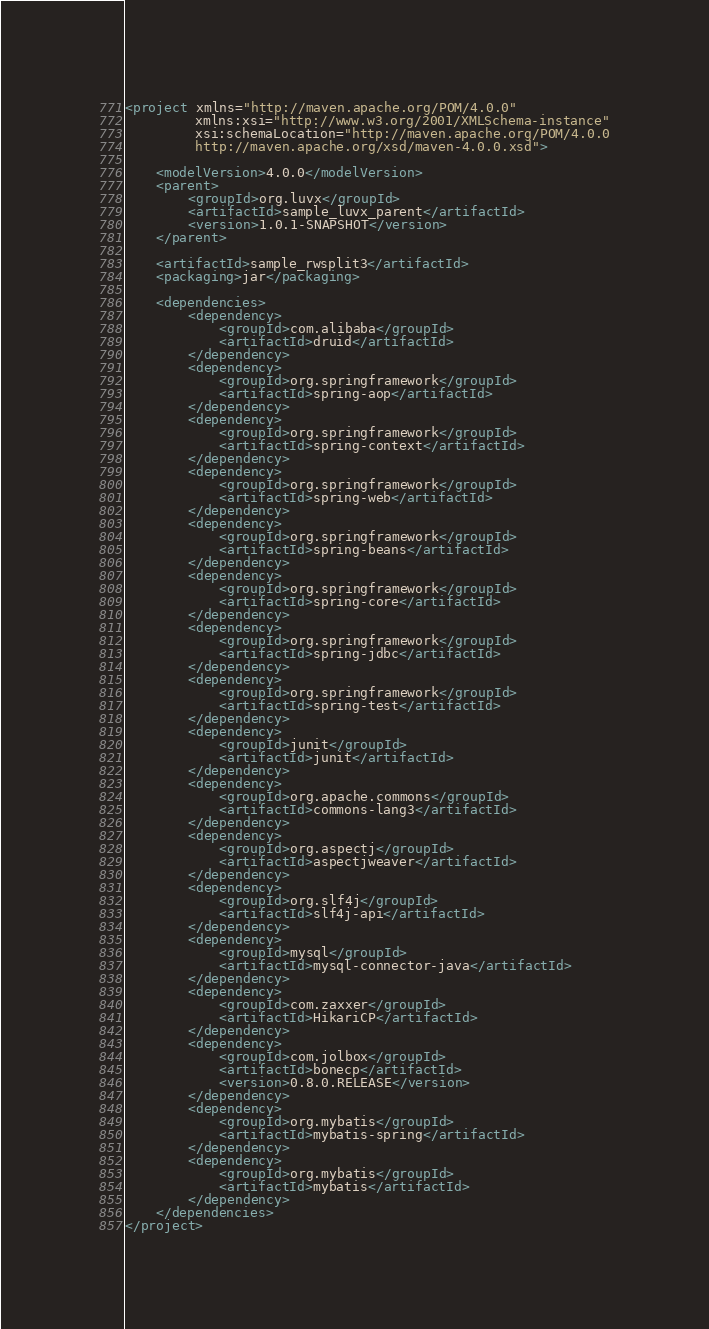<code> <loc_0><loc_0><loc_500><loc_500><_XML_><project xmlns="http://maven.apache.org/POM/4.0.0"
         xmlns:xsi="http://www.w3.org/2001/XMLSchema-instance"
         xsi:schemaLocation="http://maven.apache.org/POM/4.0.0
         http://maven.apache.org/xsd/maven-4.0.0.xsd">

    <modelVersion>4.0.0</modelVersion>
    <parent>
        <groupId>org.luvx</groupId>
        <artifactId>sample_luvx_parent</artifactId>
        <version>1.0.1-SNAPSHOT</version>
    </parent>

    <artifactId>sample_rwsplit3</artifactId>
    <packaging>jar</packaging>

    <dependencies>
        <dependency>
            <groupId>com.alibaba</groupId>
            <artifactId>druid</artifactId>
        </dependency>
        <dependency>
            <groupId>org.springframework</groupId>
            <artifactId>spring-aop</artifactId>
        </dependency>
        <dependency>
            <groupId>org.springframework</groupId>
            <artifactId>spring-context</artifactId>
        </dependency>
        <dependency>
            <groupId>org.springframework</groupId>
            <artifactId>spring-web</artifactId>
        </dependency>
        <dependency>
            <groupId>org.springframework</groupId>
            <artifactId>spring-beans</artifactId>
        </dependency>
        <dependency>
            <groupId>org.springframework</groupId>
            <artifactId>spring-core</artifactId>
        </dependency>
        <dependency>
            <groupId>org.springframework</groupId>
            <artifactId>spring-jdbc</artifactId>
        </dependency>
        <dependency>
            <groupId>org.springframework</groupId>
            <artifactId>spring-test</artifactId>
        </dependency>
        <dependency>
            <groupId>junit</groupId>
            <artifactId>junit</artifactId>
        </dependency>
        <dependency>
            <groupId>org.apache.commons</groupId>
            <artifactId>commons-lang3</artifactId>
        </dependency>
        <dependency>
            <groupId>org.aspectj</groupId>
            <artifactId>aspectjweaver</artifactId>
        </dependency>
        <dependency>
            <groupId>org.slf4j</groupId>
            <artifactId>slf4j-api</artifactId>
        </dependency>
        <dependency>
            <groupId>mysql</groupId>
            <artifactId>mysql-connector-java</artifactId>
        </dependency>
        <dependency>
            <groupId>com.zaxxer</groupId>
            <artifactId>HikariCP</artifactId>
        </dependency>
        <dependency>
            <groupId>com.jolbox</groupId>
            <artifactId>bonecp</artifactId>
            <version>0.8.0.RELEASE</version>
        </dependency>
        <dependency>
            <groupId>org.mybatis</groupId>
            <artifactId>mybatis-spring</artifactId>
        </dependency>
        <dependency>
            <groupId>org.mybatis</groupId>
            <artifactId>mybatis</artifactId>
        </dependency>
    </dependencies>
</project></code> 